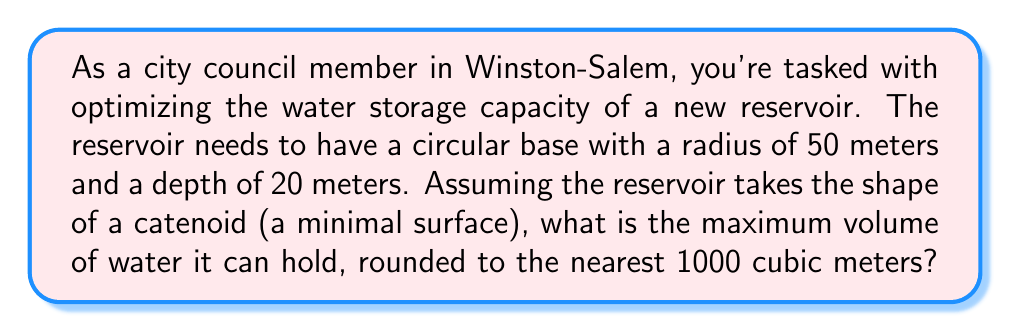Provide a solution to this math problem. To solve this problem, we'll follow these steps:

1) The equation of a catenoid in cylindrical coordinates $(r, \theta, z)$ is given by:

   $$r = a \cosh(\frac{z}{a})$$

   where $a$ is a constant that determines the shape of the catenoid.

2) We know that at the base of the reservoir, $r = 50$ and $z = 0$. Substituting these values:

   $$50 = a \cosh(0) = a$$

   So, $a = 50$.

3) The equation of our catenoid surface is now:

   $$r = 50 \cosh(\frac{z}{50})$$

4) To find the volume, we need to integrate this function over the depth of the reservoir:

   $$V = \pi \int_0^{20} [50 \cosh(\frac{z}{50})]^2 dz$$

5) Expanding this integral:

   $$V = 2500\pi \int_0^{20} \cosh^2(\frac{z}{50}) dz$$

6) Using the identity $\cosh^2(x) = \frac{1}{2}[\cosh(2x) + 1]$, we get:

   $$V = 1250\pi \int_0^{20} [\cosh(\frac{z}{25}) + 1] dz$$

7) Integrating:

   $$V = 1250\pi [25\sinh(\frac{z}{25}) + z]_0^{20}$$

8) Evaluating the limits:

   $$V = 1250\pi [25\sinh(\frac{20}{25}) + 20 - 25\sinh(0) - 0]$$
   $$V = 1250\pi [25\sinh(0.8) + 20]$$

9) Calculating:

   $$V \approx 157,079.6329... \text{ cubic meters}$$

10) Rounding to the nearest 1000 cubic meters:

    $$V \approx 157,000 \text{ cubic meters}$$
Answer: 157,000 cubic meters 